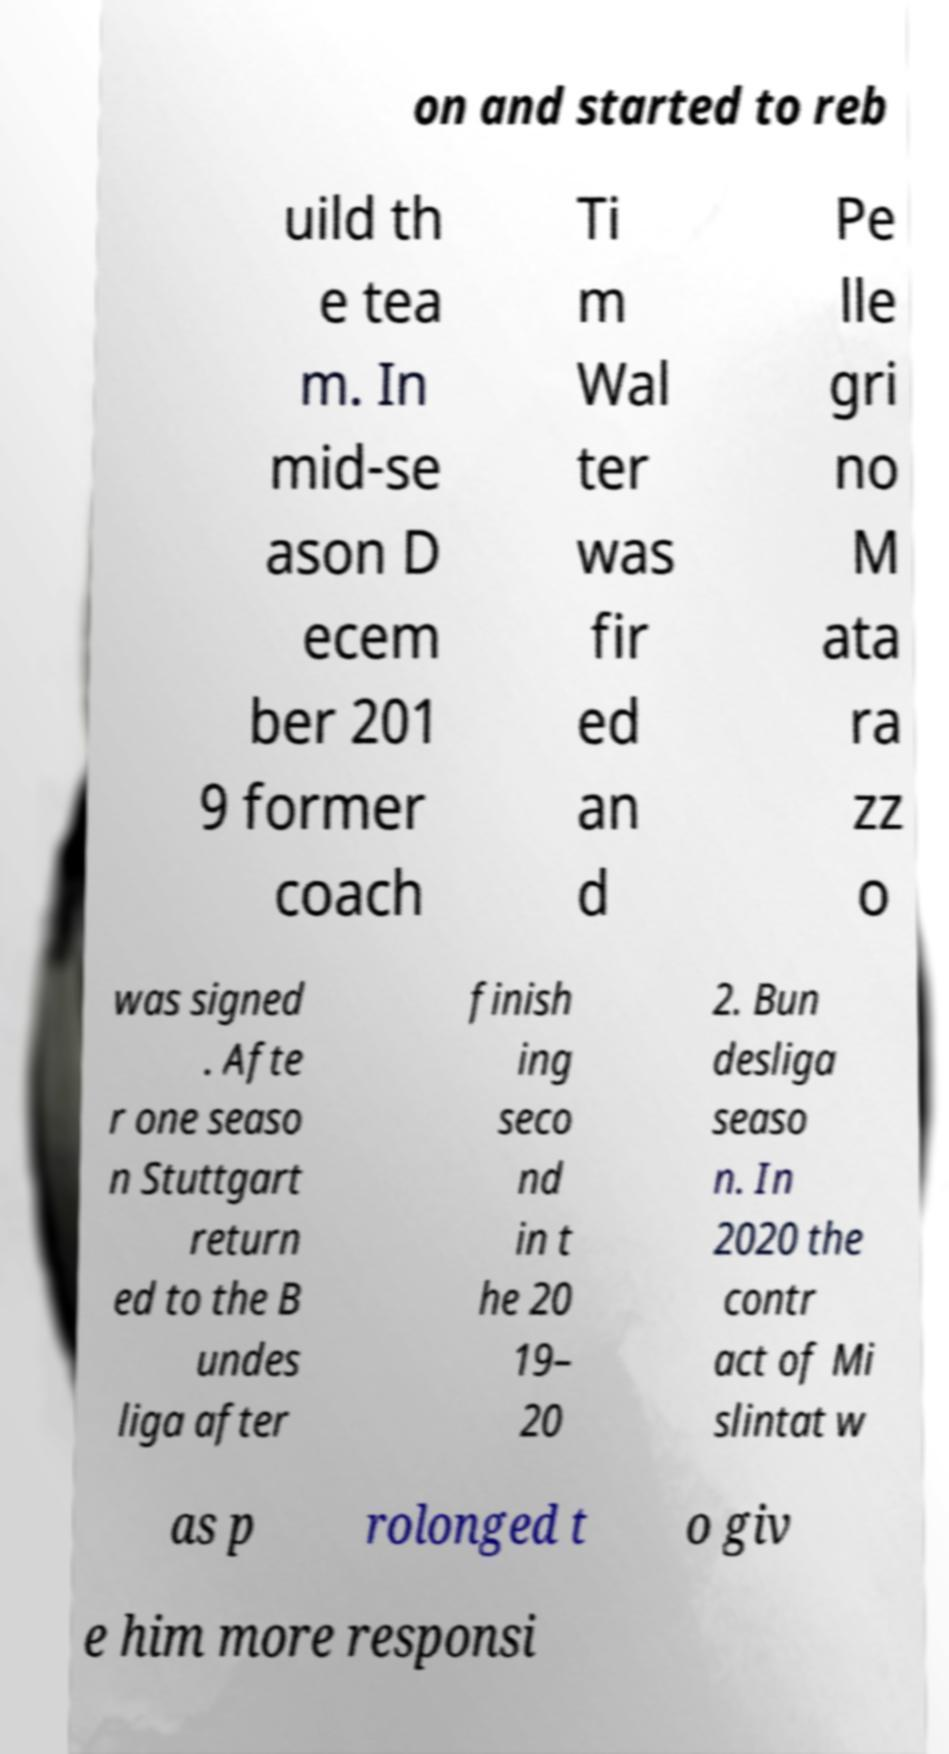There's text embedded in this image that I need extracted. Can you transcribe it verbatim? on and started to reb uild th e tea m. In mid-se ason D ecem ber 201 9 former coach Ti m Wal ter was fir ed an d Pe lle gri no M ata ra zz o was signed . Afte r one seaso n Stuttgart return ed to the B undes liga after finish ing seco nd in t he 20 19– 20 2. Bun desliga seaso n. In 2020 the contr act of Mi slintat w as p rolonged t o giv e him more responsi 